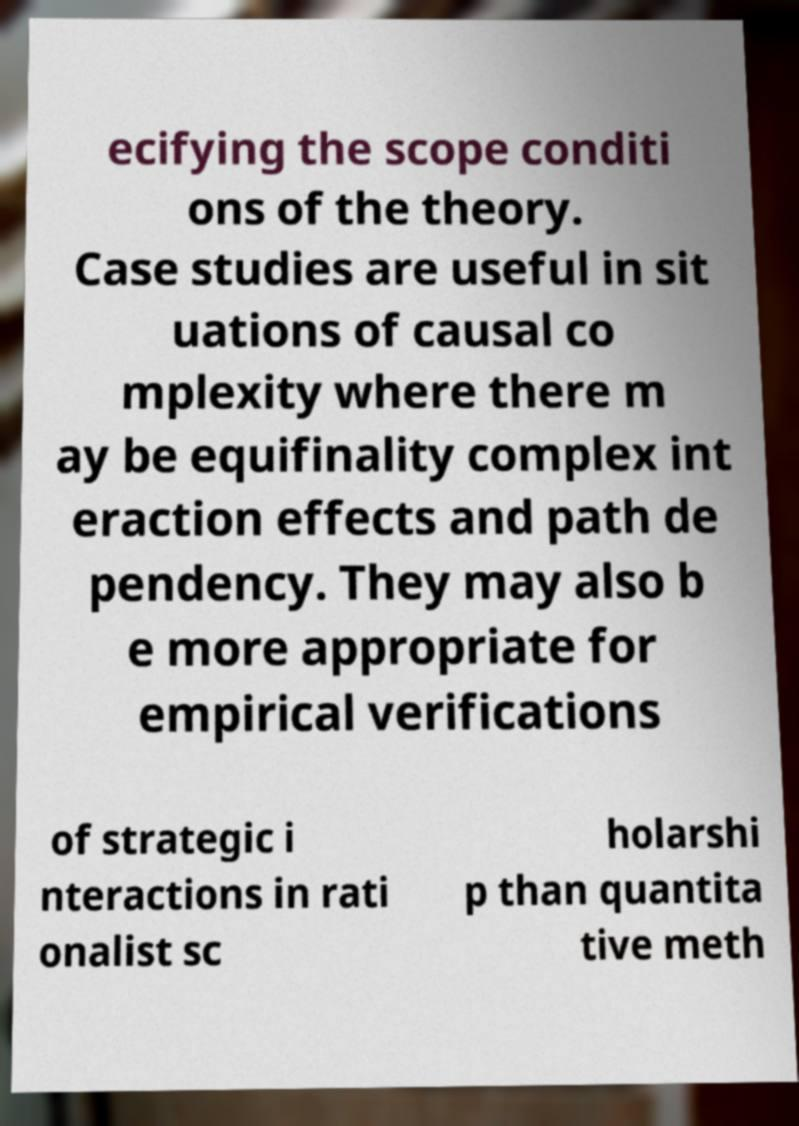Can you accurately transcribe the text from the provided image for me? ecifying the scope conditi ons of the theory. Case studies are useful in sit uations of causal co mplexity where there m ay be equifinality complex int eraction effects and path de pendency. They may also b e more appropriate for empirical verifications of strategic i nteractions in rati onalist sc holarshi p than quantita tive meth 